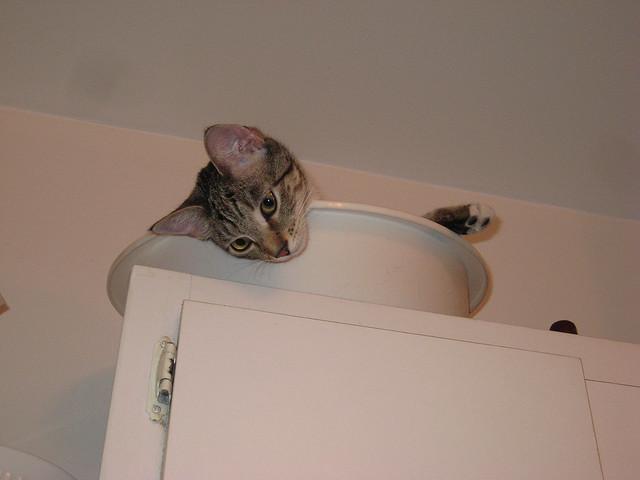What kind of animal is laying down?
Short answer required. Cat. What is the animal doing?
Concise answer only. Staring. Does the cat look happy?
Concise answer only. Yes. Are the cats hiding?
Keep it brief. Yes. What animal is shown?
Write a very short answer. Cat. Is the cat looking at the camera?
Be succinct. Yes. What is the animal sitting in?
Give a very brief answer. Bowl. What is the cat lying on?
Give a very brief answer. Bowl. What color is the cat?
Answer briefly. Gray. Why is the cat sitting on the toilet?
Quick response, please. Pee. Why do you think the animal is next to the sink?
Be succinct. Cat. Is the cat climbing down?
Answer briefly. No. What is the cat doing?
Short answer required. Looking. What room is this?
Give a very brief answer. Kitchen. Are the cats eyes open?
Quick response, please. Yes. What is this animal?
Short answer required. Cat. Does this animal look comfortable?
Be succinct. Yes. What is the cat sitting on?
Concise answer only. Bowl. What is the cat standing on?
Answer briefly. Cabinet. 